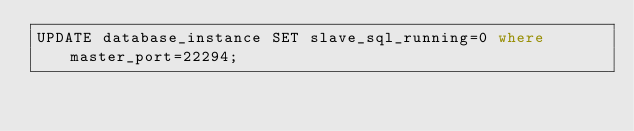Convert code to text. <code><loc_0><loc_0><loc_500><loc_500><_SQL_>UPDATE database_instance SET slave_sql_running=0 where master_port=22294;
</code> 